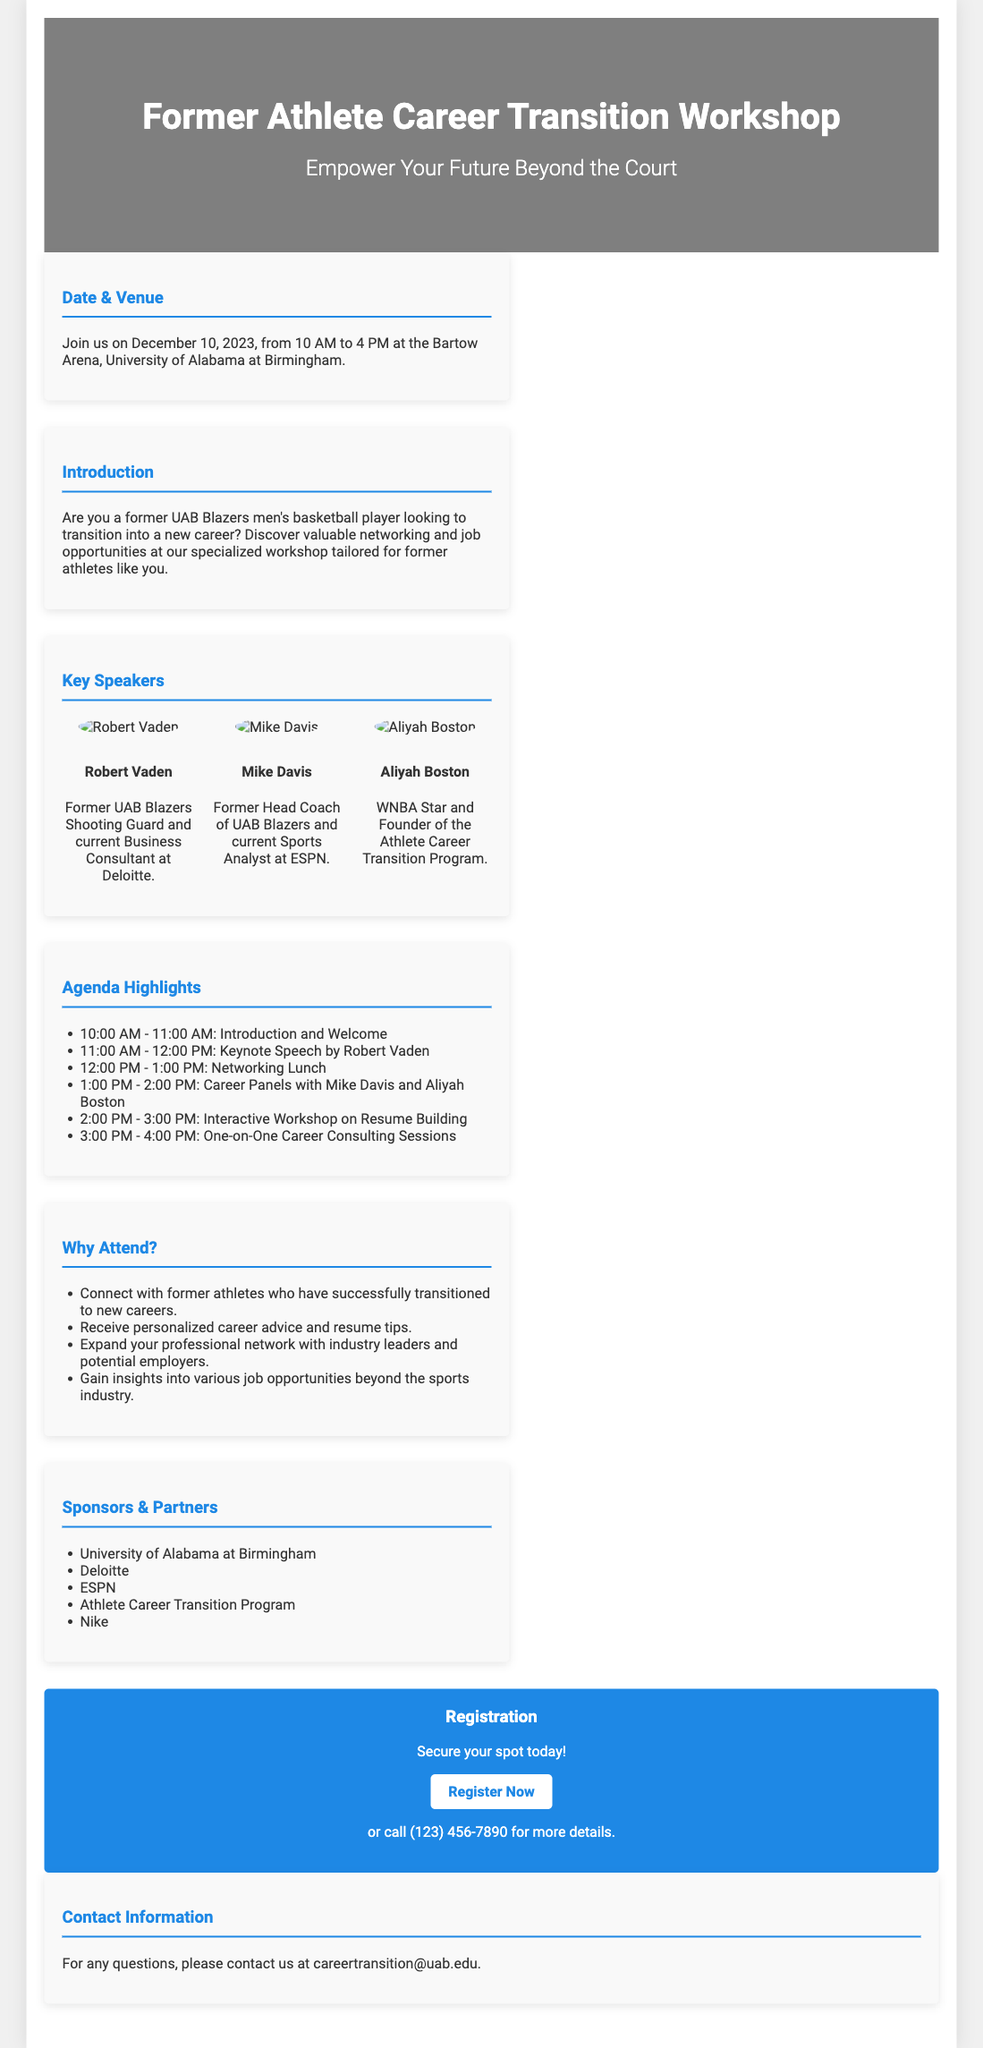What is the date of the workshop? The workshop is scheduled to take place on December 10, 2023.
Answer: December 10, 2023 Where is the workshop being held? The venue for the workshop is the Bartow Arena, University of Alabama at Birmingham.
Answer: Bartow Arena, University of Alabama at Birmingham Who is the keynote speaker? The keynote speaker for the workshop is Robert Vaden.
Answer: Robert Vaden What time does the networking lunch start? The networking lunch is scheduled to start at 12:00 PM.
Answer: 12:00 PM What is one benefit of attending the workshop? One benefit of attending is to connect with former athletes who have successfully transitioned to new careers.
Answer: Connect with former athletes How many speakers are listed in the document? There are three speakers mentioned in the document.
Answer: Three What type of session is scheduled from 3:00 PM to 4:00 PM? The session from 3:00 PM to 4:00 PM is for One-on-One Career Consulting.
Answer: One-on-One Career Consulting Which company is mentioned as a sponsor? Deloitte is mentioned as one of the sponsors.
Answer: Deloitte How can attendees register for the workshop? Attendees can register by visiting the registration link provided in the document.
Answer: Register Now 